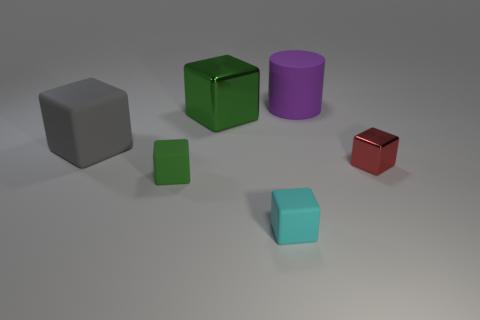Subtract all blue cubes. Subtract all gray balls. How many cubes are left? 5 Add 3 green matte objects. How many objects exist? 9 Subtract all blocks. How many objects are left? 1 Subtract 0 cyan balls. How many objects are left? 6 Subtract all large things. Subtract all gray rubber balls. How many objects are left? 3 Add 6 tiny objects. How many tiny objects are left? 9 Add 5 tiny yellow spheres. How many tiny yellow spheres exist? 5 